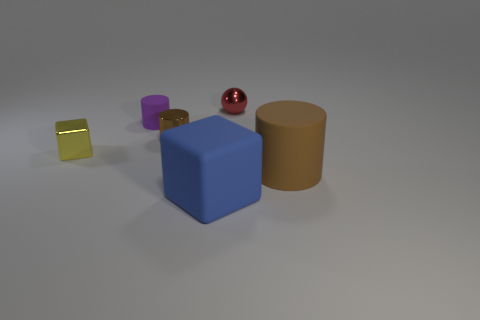What is the arrangement of the colored objects, and does it seem to follow a particular pattern? The objects are arranged unevenly across the surface without a specific pattern. There's a golden yellow glossy cube, a purple cylinder, a red sphere, and a large blue cube, each positioned separately from the others. 